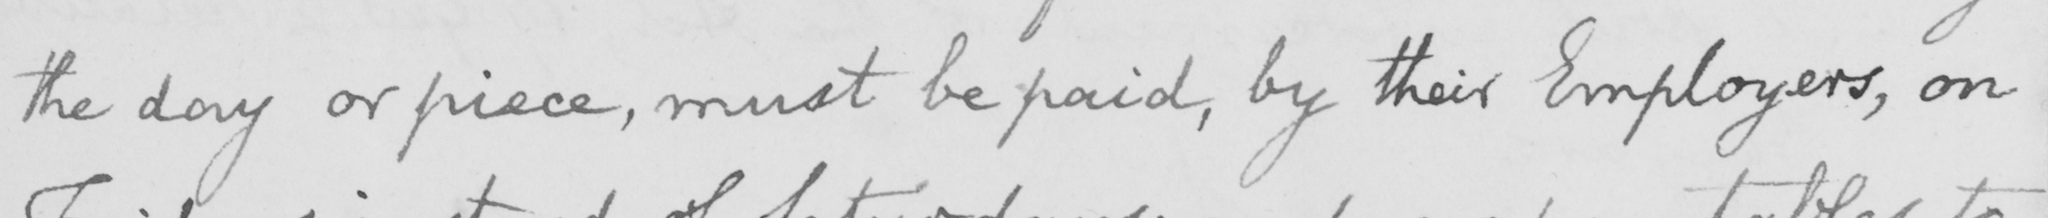What does this handwritten line say? the day or piece , must be paid , by their Employers , on 